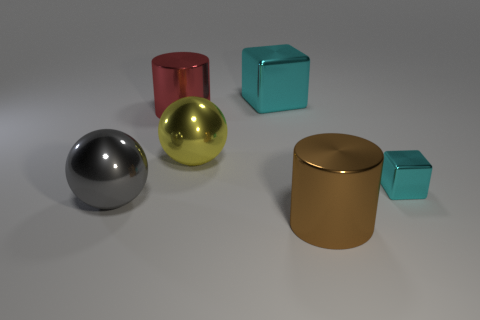There is another object that is the same shape as the tiny cyan thing; what is its color?
Offer a terse response. Cyan. What color is the shiny cylinder that is in front of the big yellow shiny ball that is right of the large red metal object?
Ensure brevity in your answer.  Brown. What is the shape of the big red metal thing?
Ensure brevity in your answer.  Cylinder. The shiny thing that is behind the large yellow sphere and in front of the large metallic cube has what shape?
Your answer should be very brief. Cylinder. There is another cylinder that is made of the same material as the red cylinder; what color is it?
Your answer should be very brief. Brown. There is a shiny object that is left of the big shiny cylinder that is left of the cyan cube that is behind the tiny cyan metallic object; what shape is it?
Offer a very short reply. Sphere. What size is the yellow ball?
Provide a short and direct response. Large. There is a big yellow object that is the same material as the small cyan thing; what is its shape?
Your answer should be compact. Sphere. Are there fewer gray metal spheres that are in front of the gray object than big green shiny cylinders?
Provide a short and direct response. No. There is a large metallic cylinder that is on the left side of the large metallic cube; what color is it?
Your response must be concise. Red. 